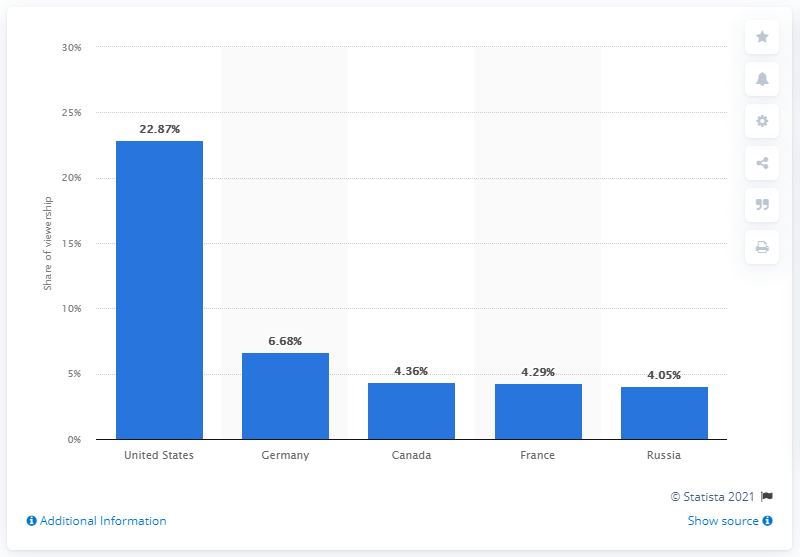Draw attention to some important aspects in this diagram. According to data from March 2021, Germany accounted for 6.68 percent of Twitch's desktop traffic. 